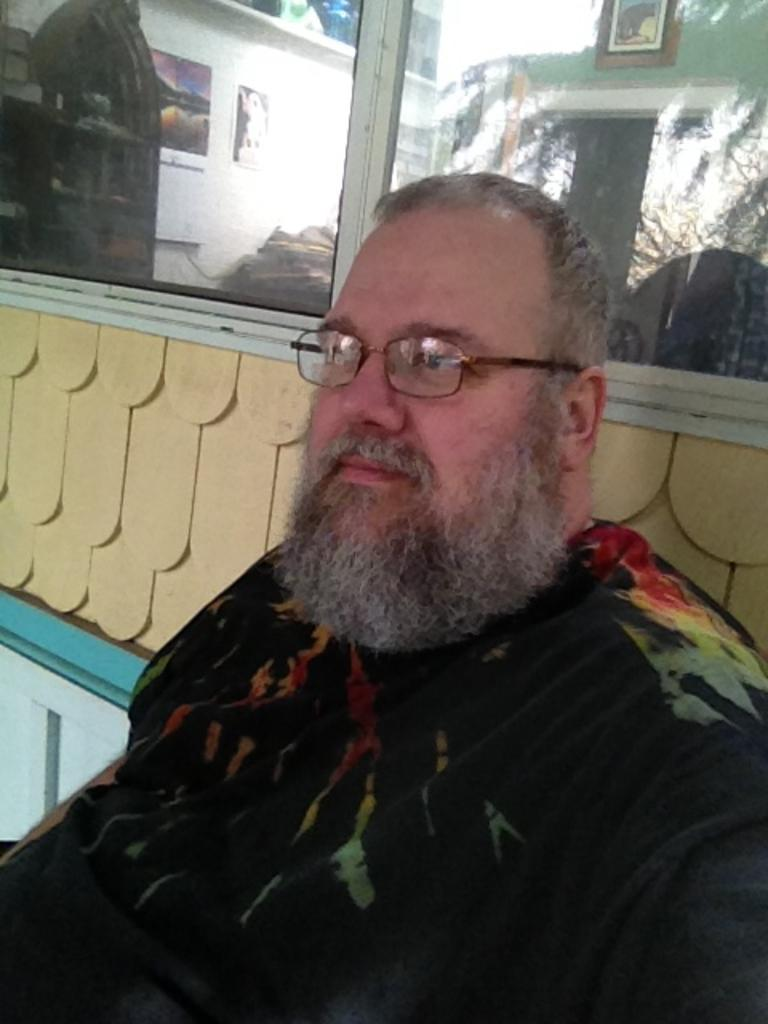What is the main subject in the foreground of the image? There is a person in the foreground of the image. What can be seen in the background of the image? There is a wall and a glass window in the background of the image. What is visible through the glass window? Photo frames and other objects are visible through the window. What type of badge is the person wearing in the image? There is no badge visible on the person in the image. How does the person express anger in the image? The image does not show any expression of anger by the person. 